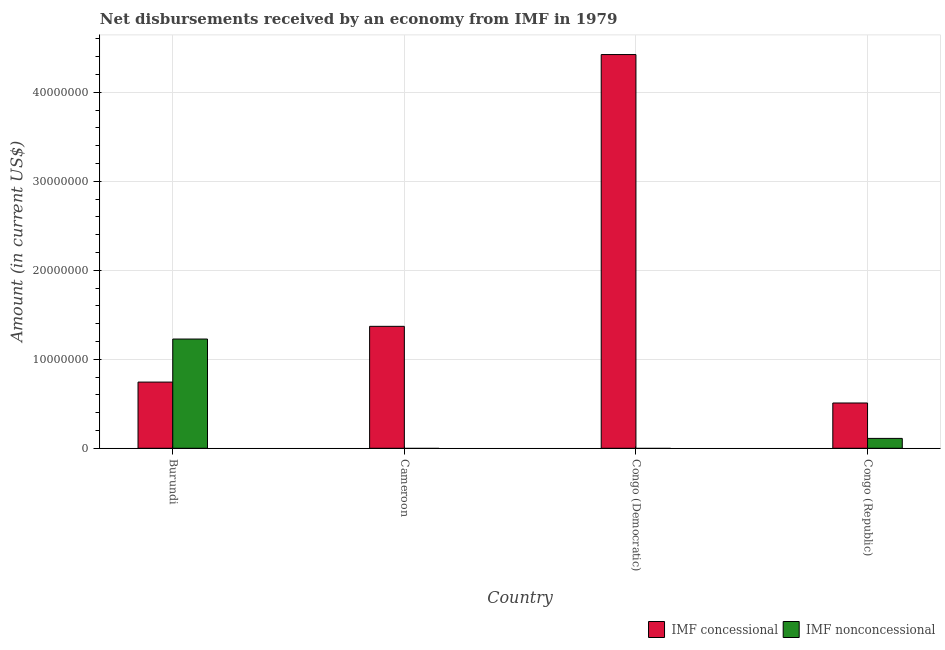How many different coloured bars are there?
Offer a very short reply. 2. Are the number of bars per tick equal to the number of legend labels?
Give a very brief answer. No. Are the number of bars on each tick of the X-axis equal?
Provide a succinct answer. No. How many bars are there on the 3rd tick from the left?
Your answer should be compact. 1. What is the label of the 3rd group of bars from the left?
Your answer should be compact. Congo (Democratic). In how many cases, is the number of bars for a given country not equal to the number of legend labels?
Make the answer very short. 2. What is the net concessional disbursements from imf in Congo (Democratic)?
Provide a short and direct response. 4.42e+07. Across all countries, what is the maximum net non concessional disbursements from imf?
Your answer should be very brief. 1.23e+07. In which country was the net non concessional disbursements from imf maximum?
Offer a terse response. Burundi. What is the total net non concessional disbursements from imf in the graph?
Ensure brevity in your answer.  1.34e+07. What is the difference between the net concessional disbursements from imf in Burundi and that in Congo (Republic)?
Make the answer very short. 2.35e+06. What is the difference between the net non concessional disbursements from imf in Congo (Republic) and the net concessional disbursements from imf in Burundi?
Ensure brevity in your answer.  -6.33e+06. What is the average net concessional disbursements from imf per country?
Keep it short and to the point. 1.76e+07. What is the difference between the net non concessional disbursements from imf and net concessional disbursements from imf in Burundi?
Your answer should be compact. 4.84e+06. What is the ratio of the net concessional disbursements from imf in Cameroon to that in Congo (Democratic)?
Give a very brief answer. 0.31. Is the net concessional disbursements from imf in Congo (Democratic) less than that in Congo (Republic)?
Your response must be concise. No. What is the difference between the highest and the second highest net concessional disbursements from imf?
Provide a succinct answer. 3.05e+07. What is the difference between the highest and the lowest net non concessional disbursements from imf?
Your answer should be very brief. 1.23e+07. In how many countries, is the net non concessional disbursements from imf greater than the average net non concessional disbursements from imf taken over all countries?
Make the answer very short. 1. Is the sum of the net concessional disbursements from imf in Burundi and Congo (Republic) greater than the maximum net non concessional disbursements from imf across all countries?
Give a very brief answer. Yes. How many bars are there?
Keep it short and to the point. 6. Are all the bars in the graph horizontal?
Your answer should be compact. No. How many countries are there in the graph?
Provide a short and direct response. 4. Are the values on the major ticks of Y-axis written in scientific E-notation?
Provide a short and direct response. No. Does the graph contain any zero values?
Make the answer very short. Yes. Does the graph contain grids?
Provide a succinct answer. Yes. How many legend labels are there?
Your answer should be compact. 2. What is the title of the graph?
Your response must be concise. Net disbursements received by an economy from IMF in 1979. What is the label or title of the Y-axis?
Offer a very short reply. Amount (in current US$). What is the Amount (in current US$) in IMF concessional in Burundi?
Keep it short and to the point. 7.44e+06. What is the Amount (in current US$) of IMF nonconcessional in Burundi?
Give a very brief answer. 1.23e+07. What is the Amount (in current US$) of IMF concessional in Cameroon?
Keep it short and to the point. 1.37e+07. What is the Amount (in current US$) in IMF nonconcessional in Cameroon?
Offer a very short reply. 0. What is the Amount (in current US$) in IMF concessional in Congo (Democratic)?
Provide a short and direct response. 4.42e+07. What is the Amount (in current US$) of IMF concessional in Congo (Republic)?
Make the answer very short. 5.09e+06. What is the Amount (in current US$) in IMF nonconcessional in Congo (Republic)?
Your response must be concise. 1.11e+06. Across all countries, what is the maximum Amount (in current US$) of IMF concessional?
Keep it short and to the point. 4.42e+07. Across all countries, what is the maximum Amount (in current US$) of IMF nonconcessional?
Keep it short and to the point. 1.23e+07. Across all countries, what is the minimum Amount (in current US$) of IMF concessional?
Give a very brief answer. 5.09e+06. Across all countries, what is the minimum Amount (in current US$) of IMF nonconcessional?
Your response must be concise. 0. What is the total Amount (in current US$) of IMF concessional in the graph?
Make the answer very short. 7.05e+07. What is the total Amount (in current US$) of IMF nonconcessional in the graph?
Offer a terse response. 1.34e+07. What is the difference between the Amount (in current US$) in IMF concessional in Burundi and that in Cameroon?
Make the answer very short. -6.26e+06. What is the difference between the Amount (in current US$) of IMF concessional in Burundi and that in Congo (Democratic)?
Make the answer very short. -3.68e+07. What is the difference between the Amount (in current US$) of IMF concessional in Burundi and that in Congo (Republic)?
Your response must be concise. 2.35e+06. What is the difference between the Amount (in current US$) of IMF nonconcessional in Burundi and that in Congo (Republic)?
Provide a short and direct response. 1.12e+07. What is the difference between the Amount (in current US$) of IMF concessional in Cameroon and that in Congo (Democratic)?
Provide a short and direct response. -3.05e+07. What is the difference between the Amount (in current US$) in IMF concessional in Cameroon and that in Congo (Republic)?
Ensure brevity in your answer.  8.61e+06. What is the difference between the Amount (in current US$) of IMF concessional in Congo (Democratic) and that in Congo (Republic)?
Your answer should be compact. 3.92e+07. What is the difference between the Amount (in current US$) in IMF concessional in Burundi and the Amount (in current US$) in IMF nonconcessional in Congo (Republic)?
Your response must be concise. 6.33e+06. What is the difference between the Amount (in current US$) in IMF concessional in Cameroon and the Amount (in current US$) in IMF nonconcessional in Congo (Republic)?
Keep it short and to the point. 1.26e+07. What is the difference between the Amount (in current US$) in IMF concessional in Congo (Democratic) and the Amount (in current US$) in IMF nonconcessional in Congo (Republic)?
Your response must be concise. 4.31e+07. What is the average Amount (in current US$) of IMF concessional per country?
Keep it short and to the point. 1.76e+07. What is the average Amount (in current US$) in IMF nonconcessional per country?
Your response must be concise. 3.35e+06. What is the difference between the Amount (in current US$) in IMF concessional and Amount (in current US$) in IMF nonconcessional in Burundi?
Provide a succinct answer. -4.84e+06. What is the difference between the Amount (in current US$) in IMF concessional and Amount (in current US$) in IMF nonconcessional in Congo (Republic)?
Offer a very short reply. 3.98e+06. What is the ratio of the Amount (in current US$) in IMF concessional in Burundi to that in Cameroon?
Provide a succinct answer. 0.54. What is the ratio of the Amount (in current US$) of IMF concessional in Burundi to that in Congo (Democratic)?
Give a very brief answer. 0.17. What is the ratio of the Amount (in current US$) in IMF concessional in Burundi to that in Congo (Republic)?
Offer a very short reply. 1.46. What is the ratio of the Amount (in current US$) of IMF nonconcessional in Burundi to that in Congo (Republic)?
Your answer should be very brief. 11.05. What is the ratio of the Amount (in current US$) of IMF concessional in Cameroon to that in Congo (Democratic)?
Your answer should be very brief. 0.31. What is the ratio of the Amount (in current US$) of IMF concessional in Cameroon to that in Congo (Republic)?
Offer a very short reply. 2.69. What is the ratio of the Amount (in current US$) of IMF concessional in Congo (Democratic) to that in Congo (Republic)?
Make the answer very short. 8.69. What is the difference between the highest and the second highest Amount (in current US$) of IMF concessional?
Your answer should be very brief. 3.05e+07. What is the difference between the highest and the lowest Amount (in current US$) of IMF concessional?
Offer a terse response. 3.92e+07. What is the difference between the highest and the lowest Amount (in current US$) of IMF nonconcessional?
Your response must be concise. 1.23e+07. 